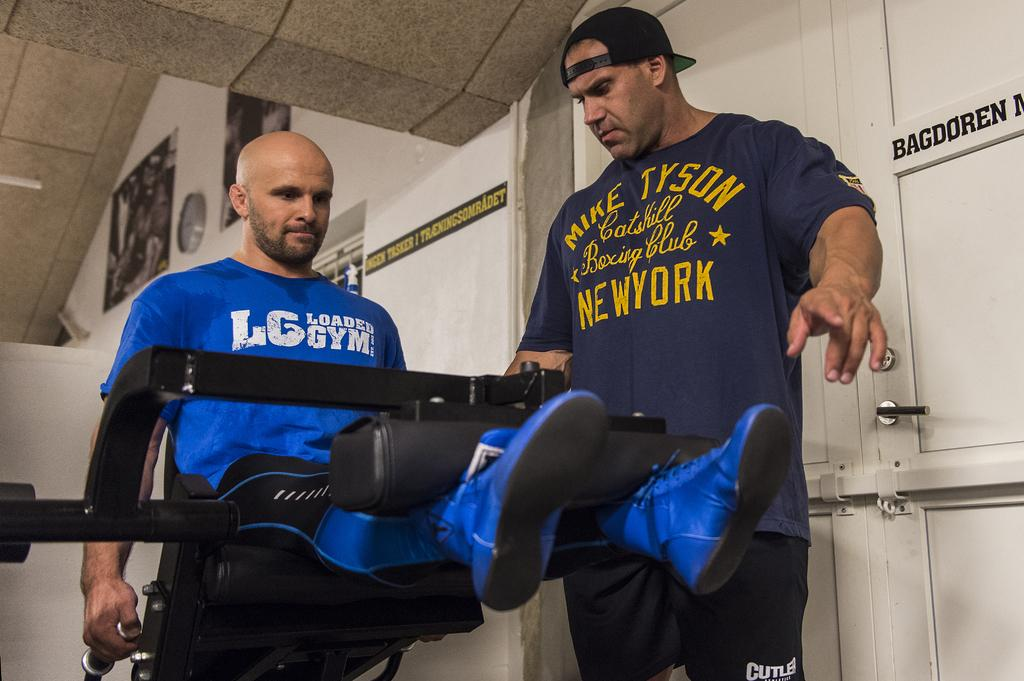Provide a one-sentence caption for the provided image. A man coaches another man who is wearing a Loaded Gym shirt. 